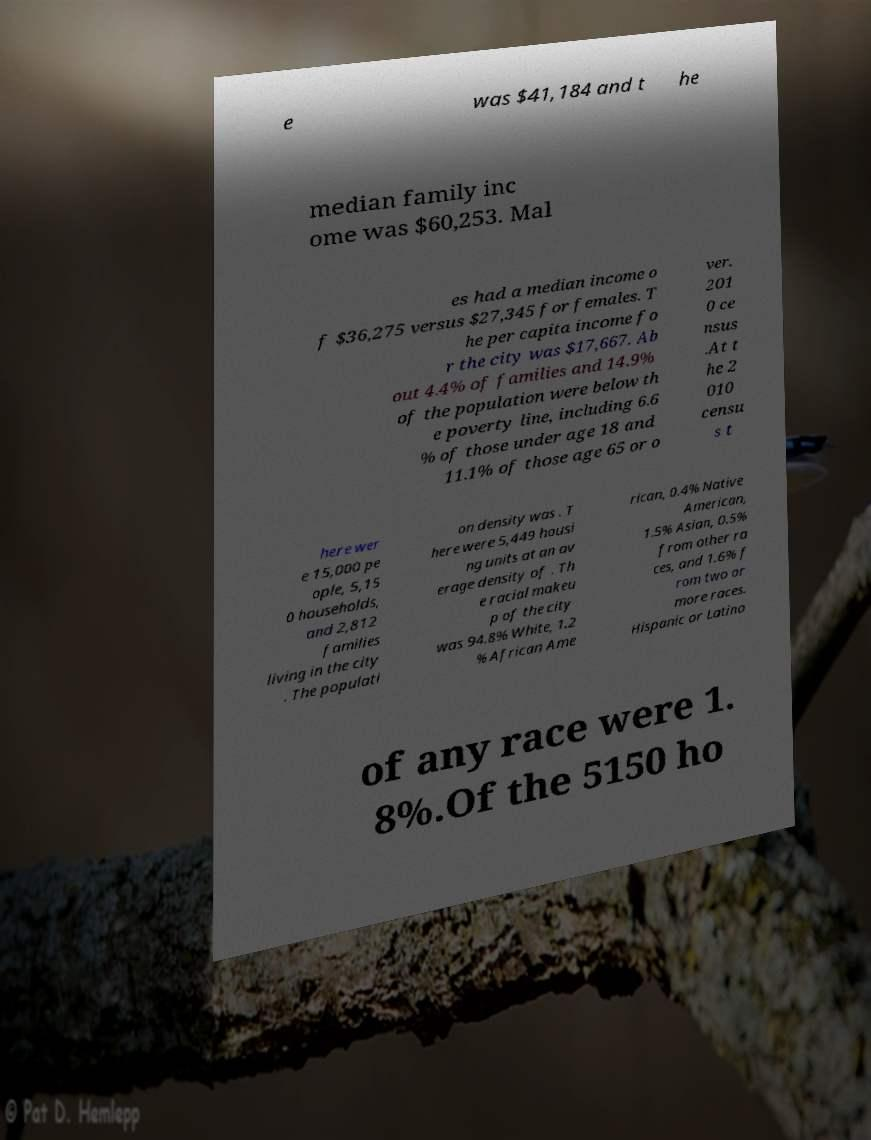Can you accurately transcribe the text from the provided image for me? e was $41,184 and t he median family inc ome was $60,253. Mal es had a median income o f $36,275 versus $27,345 for females. T he per capita income fo r the city was $17,667. Ab out 4.4% of families and 14.9% of the population were below th e poverty line, including 6.6 % of those under age 18 and 11.1% of those age 65 or o ver. 201 0 ce nsus .At t he 2 010 censu s t here wer e 15,000 pe ople, 5,15 0 households, and 2,812 families living in the city . The populati on density was . T here were 5,449 housi ng units at an av erage density of . Th e racial makeu p of the city was 94.8% White, 1.2 % African Ame rican, 0.4% Native American, 1.5% Asian, 0.5% from other ra ces, and 1.6% f rom two or more races. Hispanic or Latino of any race were 1. 8%.Of the 5150 ho 